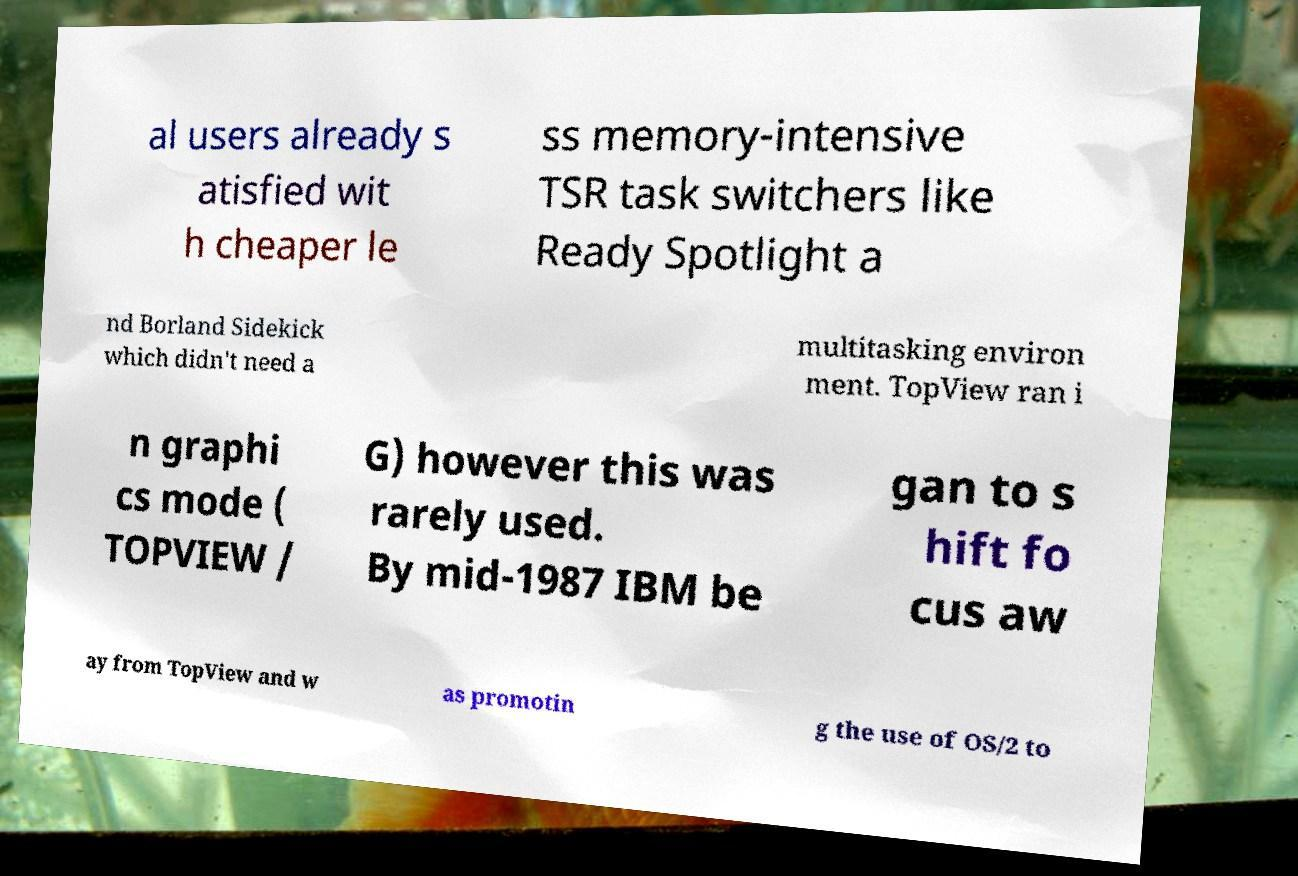What messages or text are displayed in this image? I need them in a readable, typed format. al users already s atisfied wit h cheaper le ss memory-intensive TSR task switchers like Ready Spotlight a nd Borland Sidekick which didn't need a multitasking environ ment. TopView ran i n graphi cs mode ( TOPVIEW / G) however this was rarely used. By mid-1987 IBM be gan to s hift fo cus aw ay from TopView and w as promotin g the use of OS/2 to 